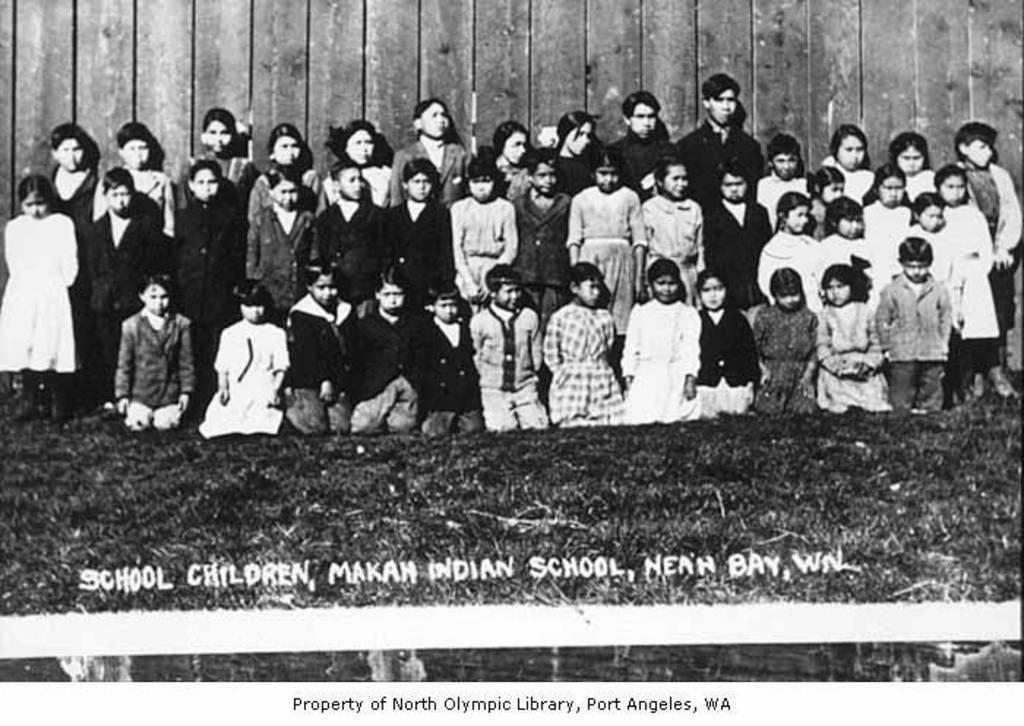How would you summarize this image in a sentence or two? This is a black and white photo. In this picture we can see some people are standing and some of them are sitting on their knees. At the bottom of the image we can see the ground and text. In the background of the image we can see the wood wall. 